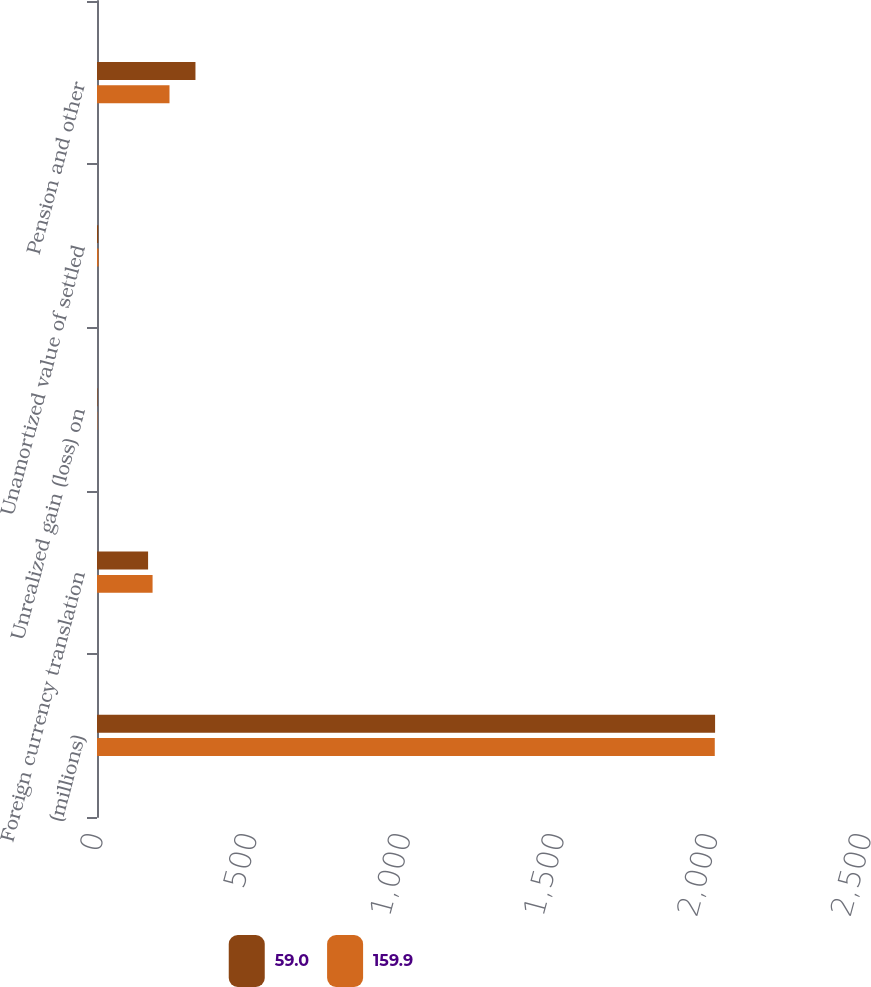Convert chart. <chart><loc_0><loc_0><loc_500><loc_500><stacked_bar_chart><ecel><fcel>(millions)<fcel>Foreign currency translation<fcel>Unrealized gain (loss) on<fcel>Unamortized value of settled<fcel>Pension and other<nl><fcel>59<fcel>2012<fcel>166.3<fcel>1.6<fcel>4.1<fcel>320.5<nl><fcel>159.9<fcel>2011<fcel>180.9<fcel>1.1<fcel>5<fcel>236<nl></chart> 